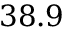Convert formula to latex. <formula><loc_0><loc_0><loc_500><loc_500>3 8 . 9</formula> 